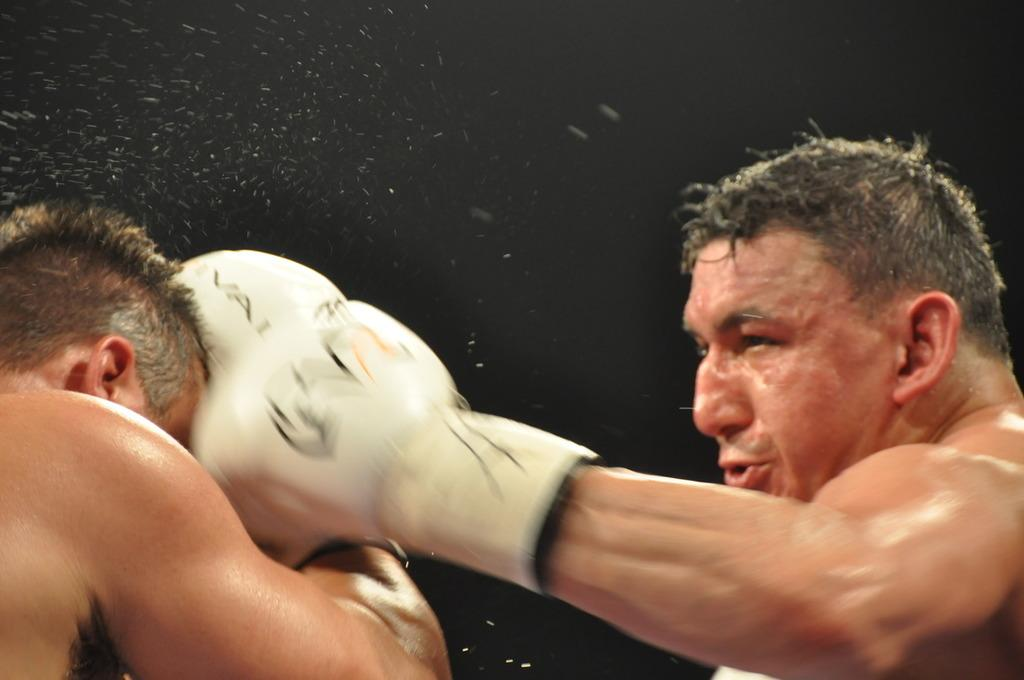How many people are in the image? There are two people in the image. What are the two people doing in the image? The two people are boxing. What direction are the geese flying in the image? There are no geese present in the image. Are the two people having any trouble while boxing in the image? The image does not provide information about any trouble the two people might be experiencing while boxing. 